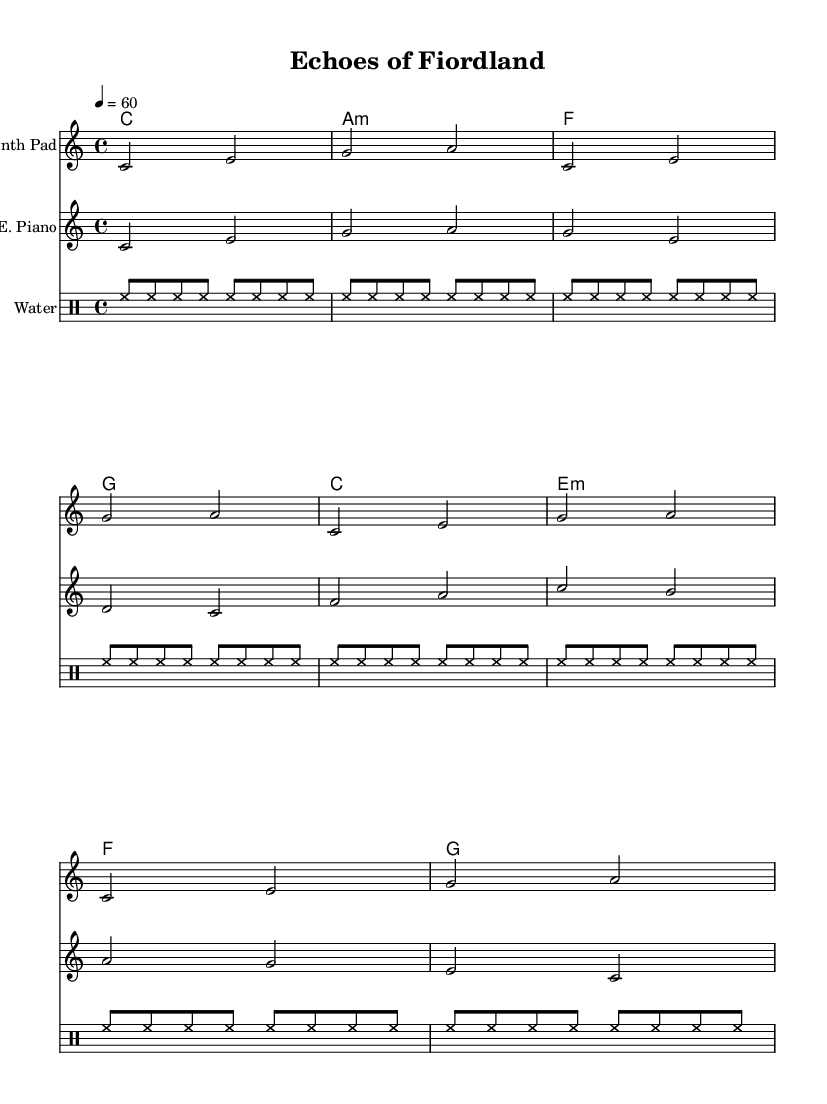What is the key signature of this music? The key signature in the sheet music is indicated by the lack of sharps or flats, which designates it as C major.
Answer: C major What is the time signature of this music? The time signature is found at the beginning of the score written as 4/4, indicating four beats per measure.
Answer: 4/4 What is the tempo marking for this piece? The tempo marking shows "4 = 60", meaning there are 60 quarter-note beats per minute, providing a slow and steady pace.
Answer: 60 How many measures are in the Synth Pad part? The Synth Pad part contains a repeated section, and counting the distinct measures gives a total of 4 measures before repeating.
Answer: 4 Which instrument has the longest note value in this score? The longest note value can be inferred from the chord names where "c1" indicates a whole note for the chord played on the synthesizer.
Answer: c1 What type of sounds are indicated in the 'Water' drum staff? The 'Water' drum staff utilizes hi-hat sounds, as denoted by the repetitive notations for the hi-hat in the drumming pattern.
Answer: hi-hat How are the chords structured throughout the music? The chords are structured following a sequence: C, A minor, F, G, which provides the harmonic foundation for the melody played by the other instruments.
Answer: C, A minor, F, G 